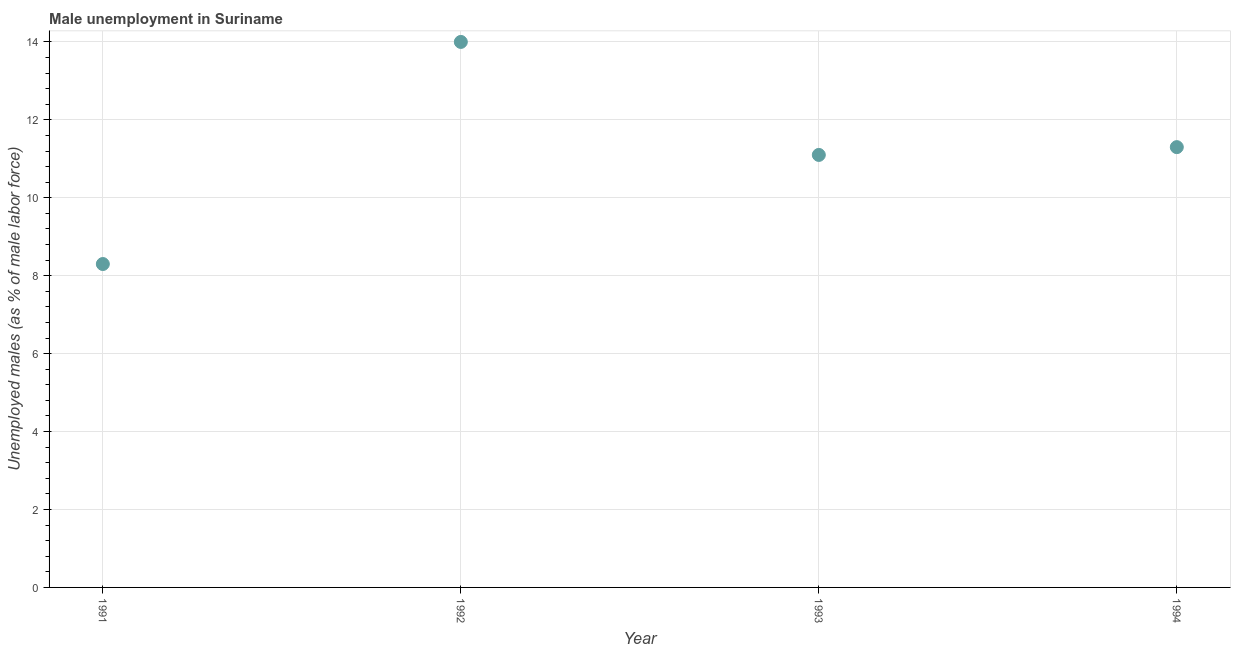What is the unemployed males population in 1994?
Provide a succinct answer. 11.3. Across all years, what is the minimum unemployed males population?
Your answer should be compact. 8.3. What is the sum of the unemployed males population?
Ensure brevity in your answer.  44.7. What is the difference between the unemployed males population in 1992 and 1993?
Offer a terse response. 2.9. What is the average unemployed males population per year?
Offer a very short reply. 11.18. What is the median unemployed males population?
Ensure brevity in your answer.  11.2. What is the ratio of the unemployed males population in 1993 to that in 1994?
Give a very brief answer. 0.98. Is the unemployed males population in 1991 less than that in 1992?
Offer a terse response. Yes. What is the difference between the highest and the second highest unemployed males population?
Provide a short and direct response. 2.7. Is the sum of the unemployed males population in 1993 and 1994 greater than the maximum unemployed males population across all years?
Provide a short and direct response. Yes. What is the difference between the highest and the lowest unemployed males population?
Your response must be concise. 5.7. How many dotlines are there?
Your answer should be compact. 1. How many years are there in the graph?
Ensure brevity in your answer.  4. What is the difference between two consecutive major ticks on the Y-axis?
Your answer should be compact. 2. Does the graph contain grids?
Your answer should be compact. Yes. What is the title of the graph?
Your answer should be compact. Male unemployment in Suriname. What is the label or title of the Y-axis?
Offer a terse response. Unemployed males (as % of male labor force). What is the Unemployed males (as % of male labor force) in 1991?
Your answer should be very brief. 8.3. What is the Unemployed males (as % of male labor force) in 1992?
Your answer should be compact. 14. What is the Unemployed males (as % of male labor force) in 1993?
Your answer should be very brief. 11.1. What is the Unemployed males (as % of male labor force) in 1994?
Give a very brief answer. 11.3. What is the difference between the Unemployed males (as % of male labor force) in 1991 and 1992?
Make the answer very short. -5.7. What is the difference between the Unemployed males (as % of male labor force) in 1991 and 1993?
Offer a very short reply. -2.8. What is the difference between the Unemployed males (as % of male labor force) in 1991 and 1994?
Offer a very short reply. -3. What is the ratio of the Unemployed males (as % of male labor force) in 1991 to that in 1992?
Your answer should be compact. 0.59. What is the ratio of the Unemployed males (as % of male labor force) in 1991 to that in 1993?
Your answer should be compact. 0.75. What is the ratio of the Unemployed males (as % of male labor force) in 1991 to that in 1994?
Provide a short and direct response. 0.73. What is the ratio of the Unemployed males (as % of male labor force) in 1992 to that in 1993?
Provide a succinct answer. 1.26. What is the ratio of the Unemployed males (as % of male labor force) in 1992 to that in 1994?
Your response must be concise. 1.24. What is the ratio of the Unemployed males (as % of male labor force) in 1993 to that in 1994?
Provide a succinct answer. 0.98. 